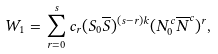<formula> <loc_0><loc_0><loc_500><loc_500>W _ { 1 } = \sum _ { r = 0 } ^ { s } c _ { r } ( S _ { 0 } { \overline { S } } ) ^ { ( s - r ) k } ( N ^ { c } _ { 0 } { \overline { N } ^ { c } } ) ^ { r } ,</formula> 